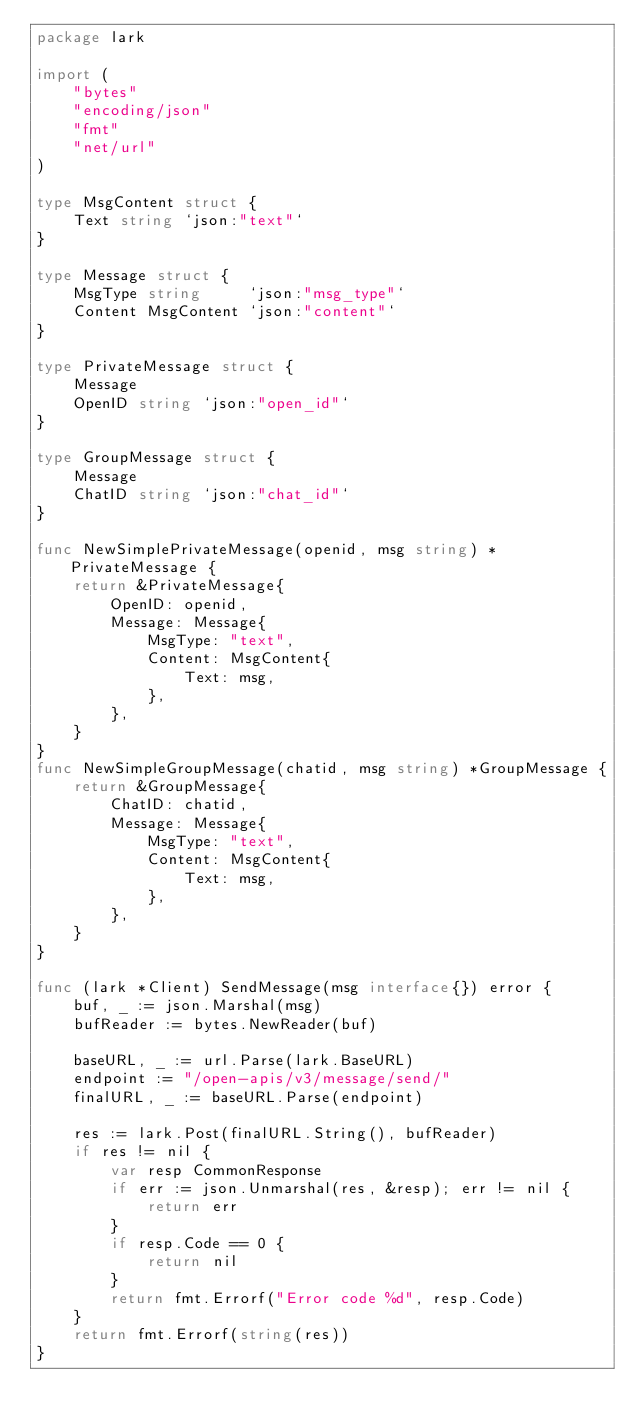<code> <loc_0><loc_0><loc_500><loc_500><_Go_>package lark

import (
	"bytes"
	"encoding/json"
	"fmt"
	"net/url"
)

type MsgContent struct {
	Text string `json:"text"`
}

type Message struct {
	MsgType string     `json:"msg_type"`
	Content MsgContent `json:"content"`
}

type PrivateMessage struct {
	Message
	OpenID string `json:"open_id"`
}

type GroupMessage struct {
	Message
	ChatID string `json:"chat_id"`
}

func NewSimplePrivateMessage(openid, msg string) *PrivateMessage {
	return &PrivateMessage{
		OpenID: openid,
		Message: Message{
			MsgType: "text",
			Content: MsgContent{
				Text: msg,
			},
		},
	}
}
func NewSimpleGroupMessage(chatid, msg string) *GroupMessage {
	return &GroupMessage{
		ChatID: chatid,
		Message: Message{
			MsgType: "text",
			Content: MsgContent{
				Text: msg,
			},
		},
	}
}

func (lark *Client) SendMessage(msg interface{}) error {
	buf, _ := json.Marshal(msg)
	bufReader := bytes.NewReader(buf)

	baseURL, _ := url.Parse(lark.BaseURL)
	endpoint := "/open-apis/v3/message/send/"
	finalURL, _ := baseURL.Parse(endpoint)

	res := lark.Post(finalURL.String(), bufReader)
	if res != nil {
		var resp CommonResponse
		if err := json.Unmarshal(res, &resp); err != nil {
			return err
		}
		if resp.Code == 0 {
			return nil
		}
		return fmt.Errorf("Error code %d", resp.Code)
	}
	return fmt.Errorf(string(res))
}
</code> 